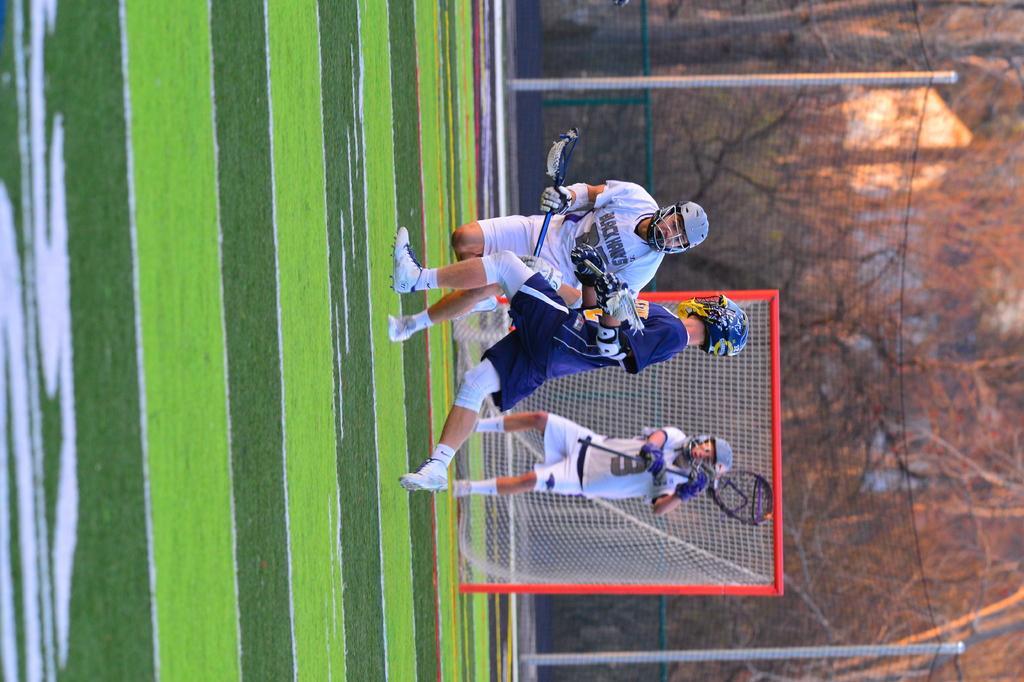Please provide a concise description of this image. There are three people wearing helmet and goggles also they are holding bats. Behind them there is a net. On the ground there is grass. In the background there are trees. 